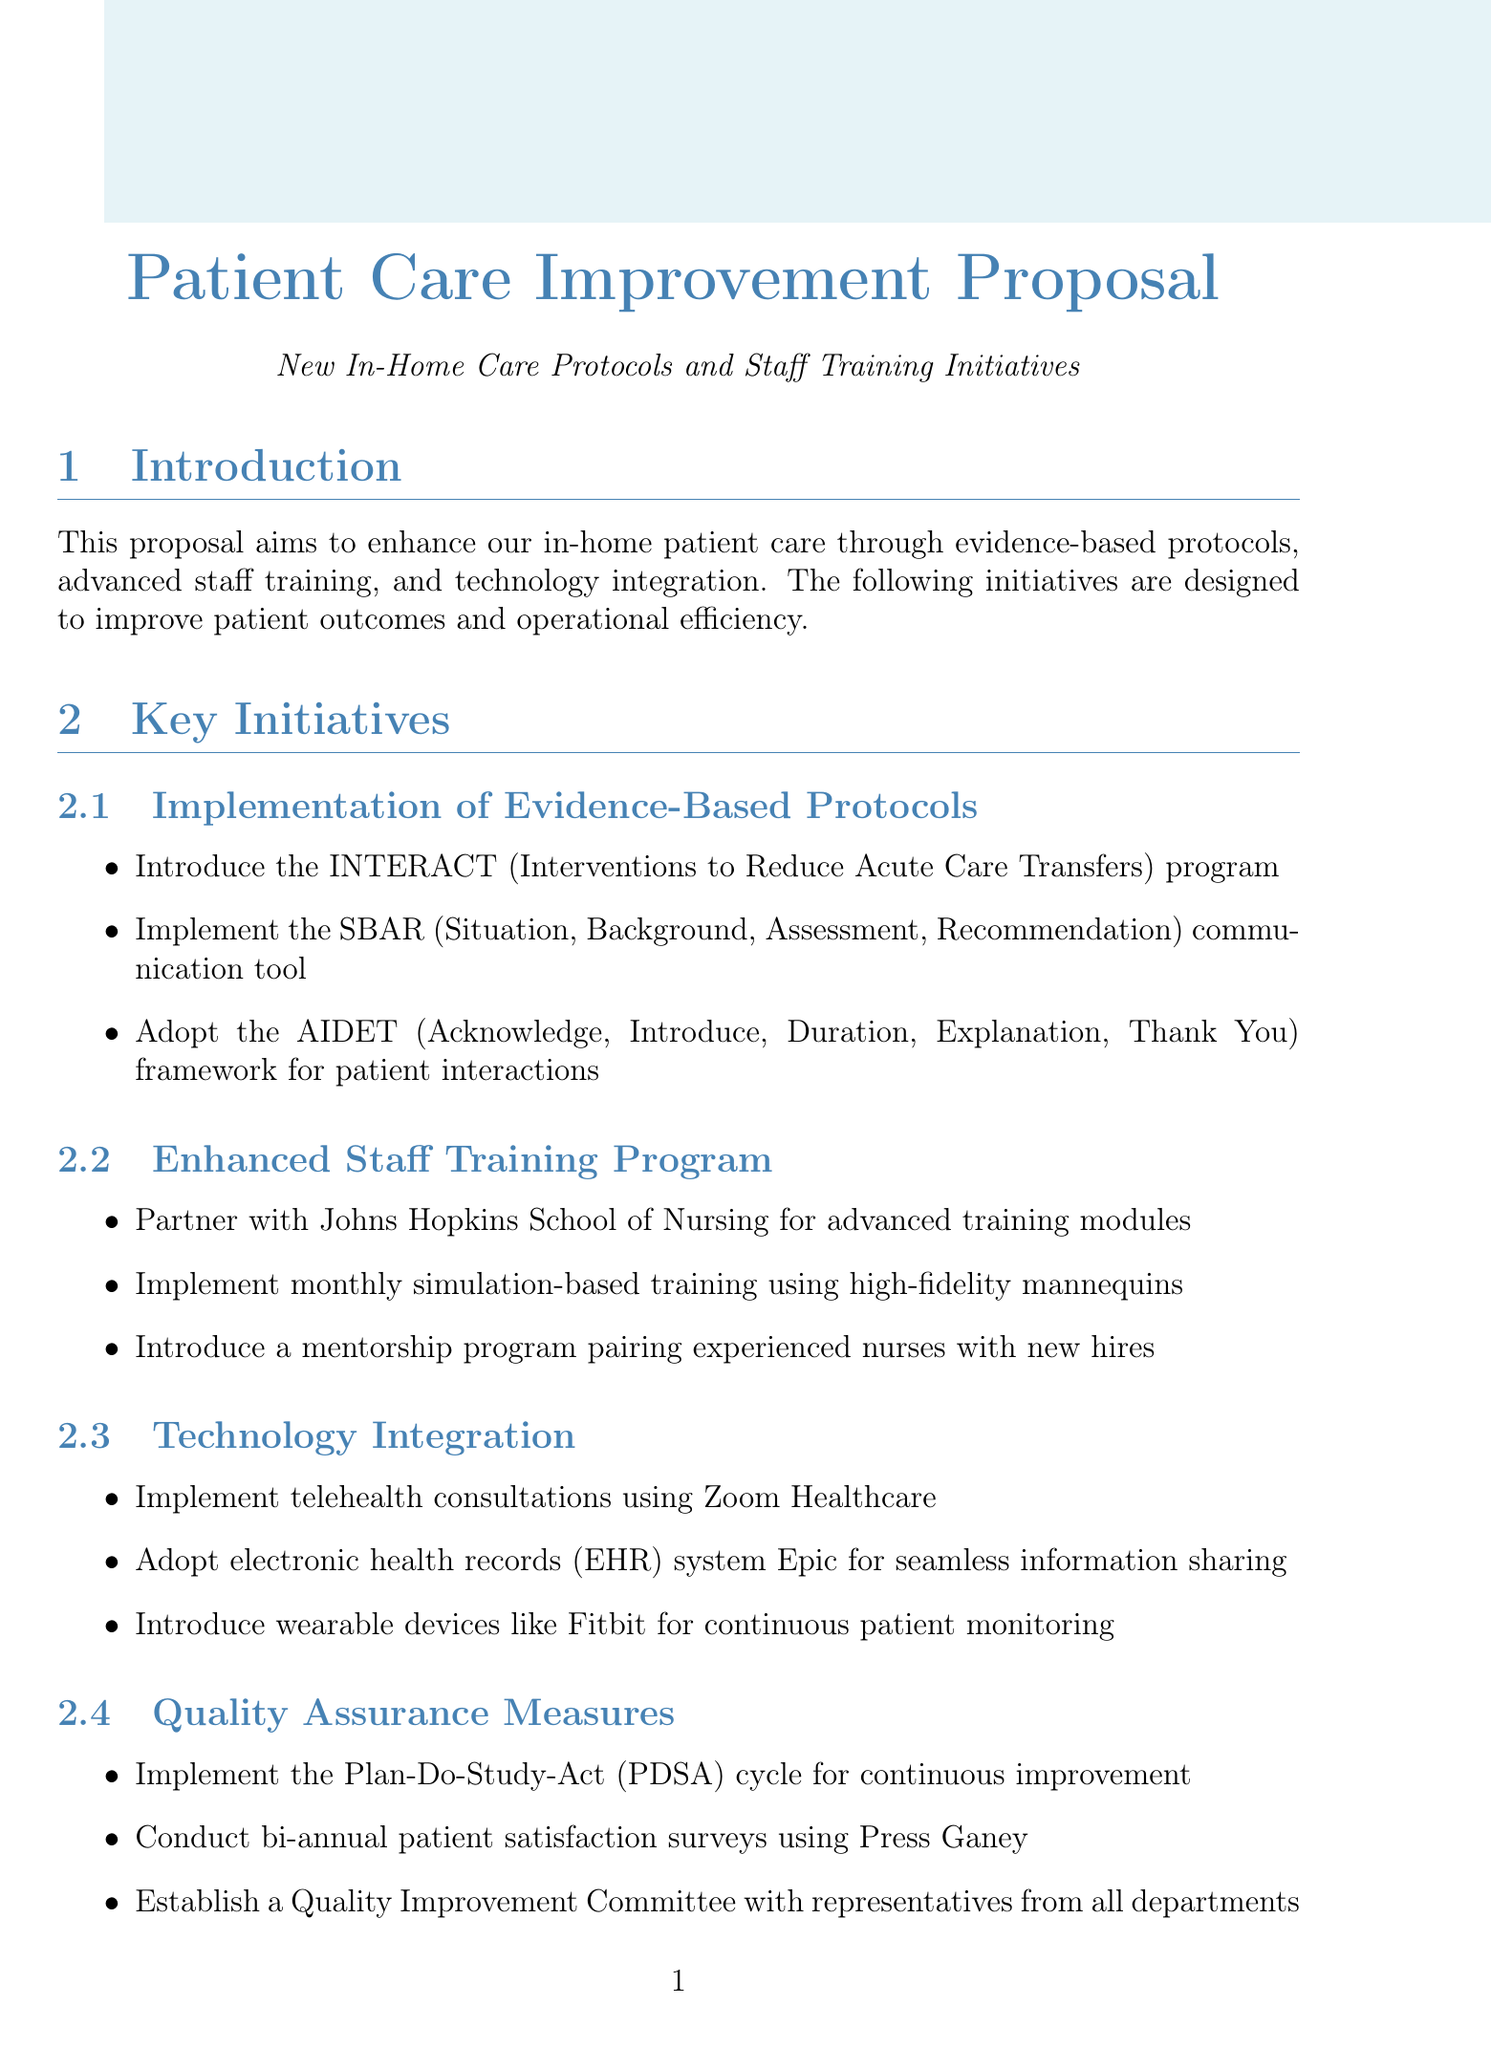What is the estimated cost of the proposal? The estimated cost is mentioned in the budget considerations section of the document.
Answer: $250,000 What program is introduced to reduce acute care transfers? The document specifically mentions a program aimed at reducing acute care transfers.
Answer: INTERACT How much is allocated for staff training and development? The budget breakdown itemizes the cost for staff training and development in the document.
Answer: $100,000 What is the duration of Phase 1 in the implementation timeline? The implementation timeline section outlines the duration for each phase.
Answer: 3 months What technology is used for telehealth consultations? The document refers to a specific technology implemented for telehealth consultations.
Answer: Zoom Healthcare What is the expected reduction in hospital readmissions within 30 days? The expected outcomes section lists the targets for improvement in patient care.
Answer: 20% What framework is adopted for patient interactions? The document describes a framework aimed at improving patient interactions.
Answer: AIDET How many months is the training program with Johns Hopkins School of Nursing? The document suggests a partnership for training but does not specify the number of months.
Answer: Not specified Which committee is established for quality assurance? The document mentions a specific committee dedicated to quality improvement.
Answer: Quality Improvement Committee 